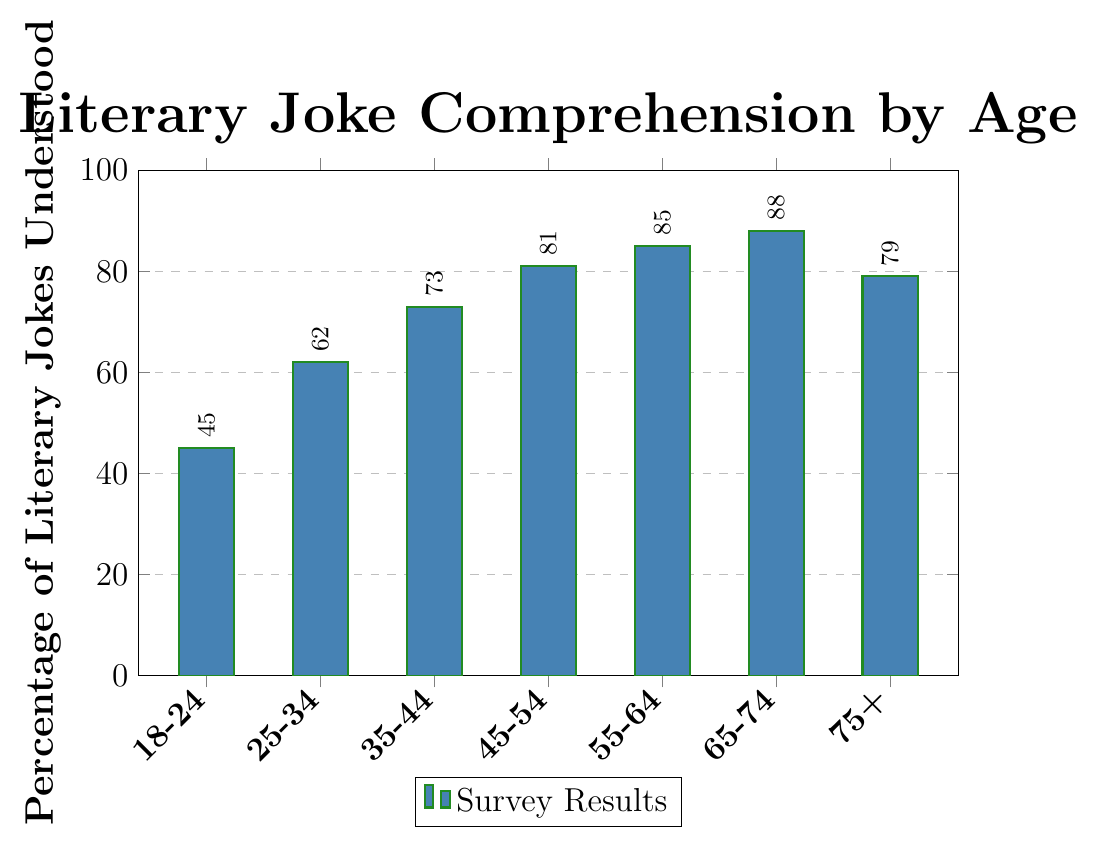What's the percentage of literary jokes understood by the 35-44 age group? Look at the height of the bar labeled "35-44" and read the corresponding percentage.
Answer: 73 Which age group has the highest percentage of literary jokes understood? Compare the heights of all the bars and identify the tallest bar, which represents the highest percentage.
Answer: 65-74 How much does the understanding of literary jokes increase from the 18-24 age group to the 25-34 age group? Subtract the percentage of the 18-24 age group (45) from the percentage of the 25-34 age group (62). 62 - 45 = 17
Answer: 17 What's the average percentage of literary jokes understood across all age groups? Add all the percentages and divide by the number of age groups. (45 + 62 + 73 + 81 + 85 + 88 + 79) / 7 = 513 / 7 = 73.29
Answer: 73.29 Which age groups have a lower percentage of understanding literary jokes than the 75+ age group? Compare each age group’s percentage to that of the 75+ age group (79) and list those with lower percentages.
Answer: 18-24, 25-34, 35-44, 45-54 Between which two consecutive age groups is the largest increase in literary joke comprehension observed? Calculate the differences between consecutive age groups and find the maximum. (62-45=17, 73-62=11, 81-73=8, 85-81=4, 88-85=3, 79-88=-9). The largest increase is between 18-24 and 25-34.
Answer: 18-24 and 25-34 Which age group shows a slight drop in the percentage of literary jokes understood compared to the previous group? Observe the bars and identify the age group where the percentage drops compared to the immediate previous age group.
Answer: 75+ What’s the difference in literary joke understanding percentage between the youngest and oldest age groups? Subtract the percentage of the 18-24 age group (45) from the percentage of the 75+ age group (79). 79 - 45 = 34
Answer: 34 What color is the bar representing the age group 55-64? Identify the color used to fill the bar for the age group 55-64.
Answer: Blue 